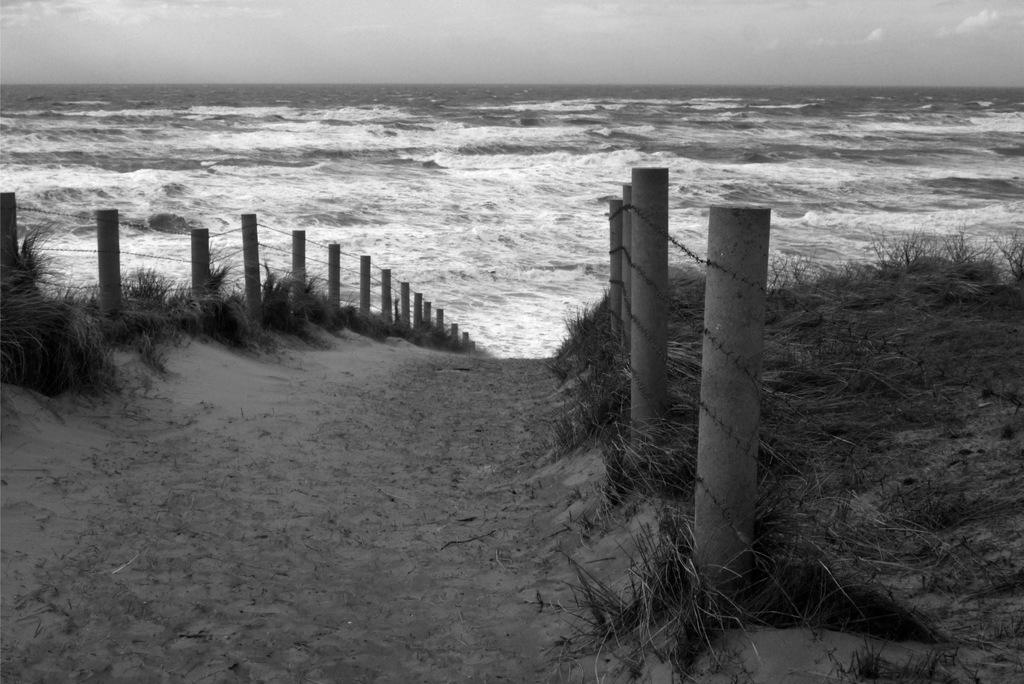What is the color scheme of the image? The image is black and white. What can be seen in the background of the image? There is an ocean in the background of the image. What is located in the foreground of the image? There is a path in the foreground of the image. What surrounds the path on either side? There is a fence on either side of the path. What type of vegetation is present on the land? There is grass on the land. What is visible above the land? The sky is visible above the land. How many oranges are hanging from the fence in the image? There are no oranges present in the image; the fence surrounds a path with grass on the land. What type of bird can be seen perched on the fence in the image? There are no birds visible in the image, only a path, a fence, grass, and an ocean in the background. 